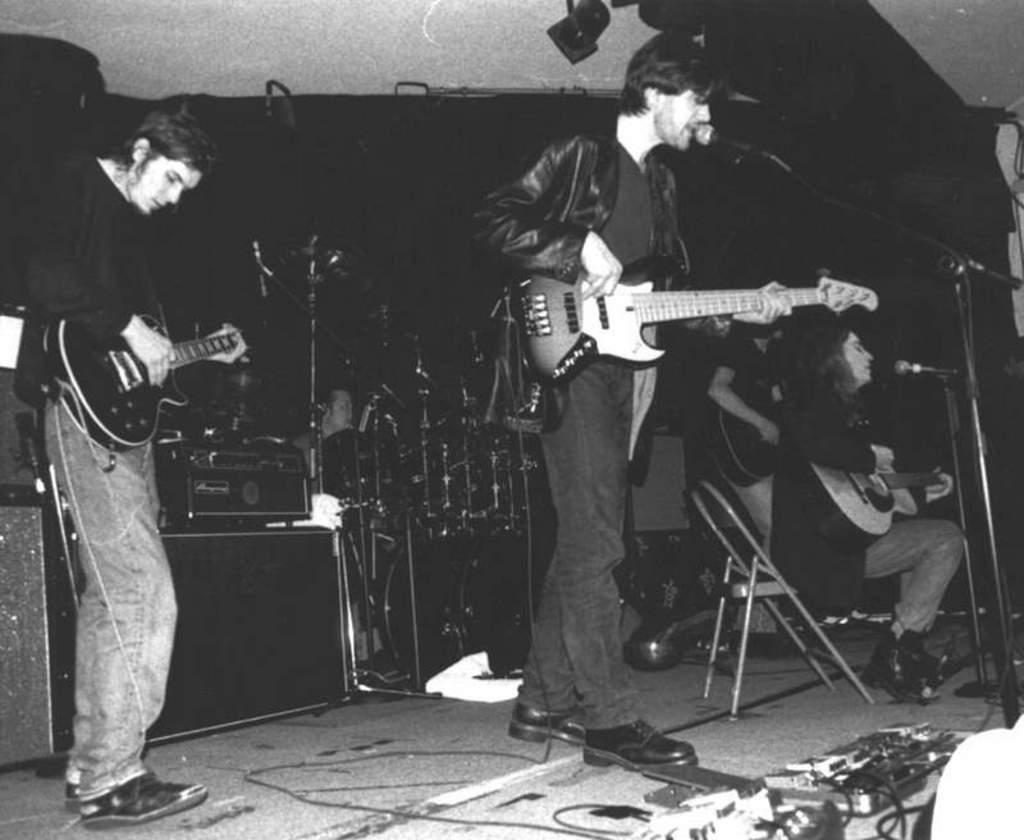In one or two sentences, can you explain what this image depicts? The image is inside the room. In the image there are group of people playing their musical instruments in front of a microphone, in background we can see another person playing musical instruments,speaker at bottom we can also see switch board and few wires. 